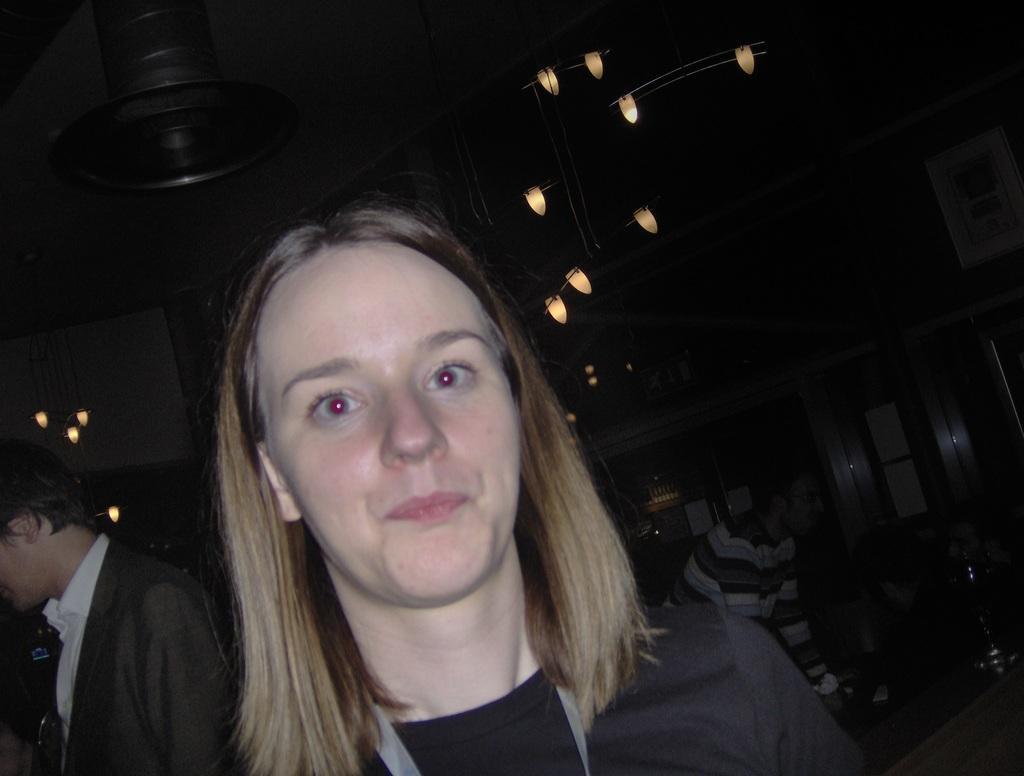Describe this image in one or two sentences. In this image I can see few people with different color dresses. There are lights in the top. I can also see the boards to the wall. And there is a black background. 